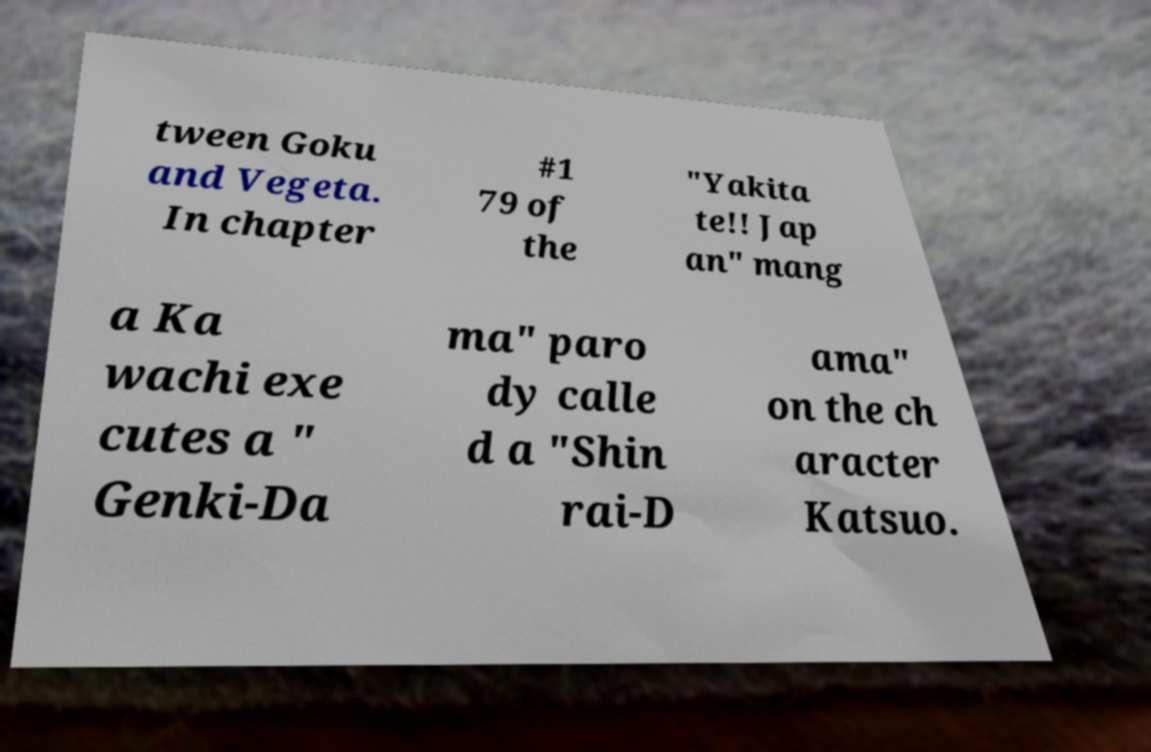Please identify and transcribe the text found in this image. tween Goku and Vegeta. In chapter #1 79 of the "Yakita te!! Jap an" mang a Ka wachi exe cutes a " Genki-Da ma" paro dy calle d a "Shin rai-D ama" on the ch aracter Katsuo. 